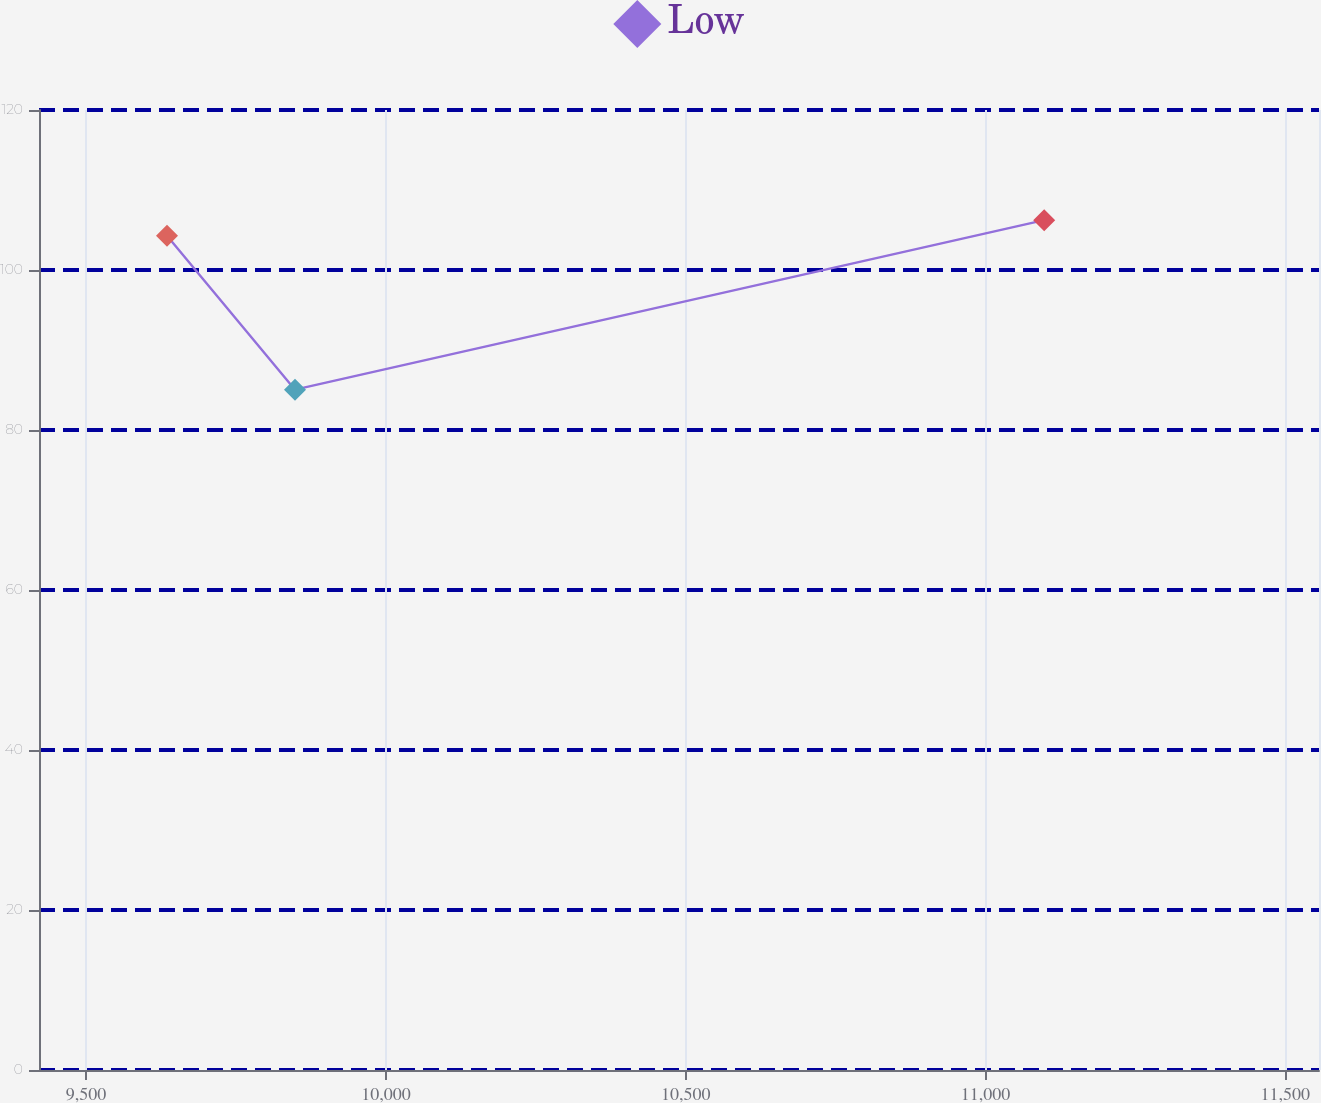Convert chart. <chart><loc_0><loc_0><loc_500><loc_500><line_chart><ecel><fcel>Low<nl><fcel>9634.93<fcel>104.27<nl><fcel>9848.4<fcel>85.04<nl><fcel>11097.8<fcel>106.23<nl><fcel>11769.6<fcel>89.49<nl></chart> 